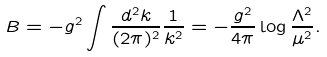Convert formula to latex. <formula><loc_0><loc_0><loc_500><loc_500>B = - g ^ { 2 } \int \frac { d ^ { 2 } k } { ( 2 \pi ) ^ { 2 } } \frac { 1 } { k ^ { 2 } } = - \frac { g ^ { 2 } } { 4 \pi } \log \frac { \Lambda ^ { 2 } } { \mu ^ { 2 } } .</formula> 